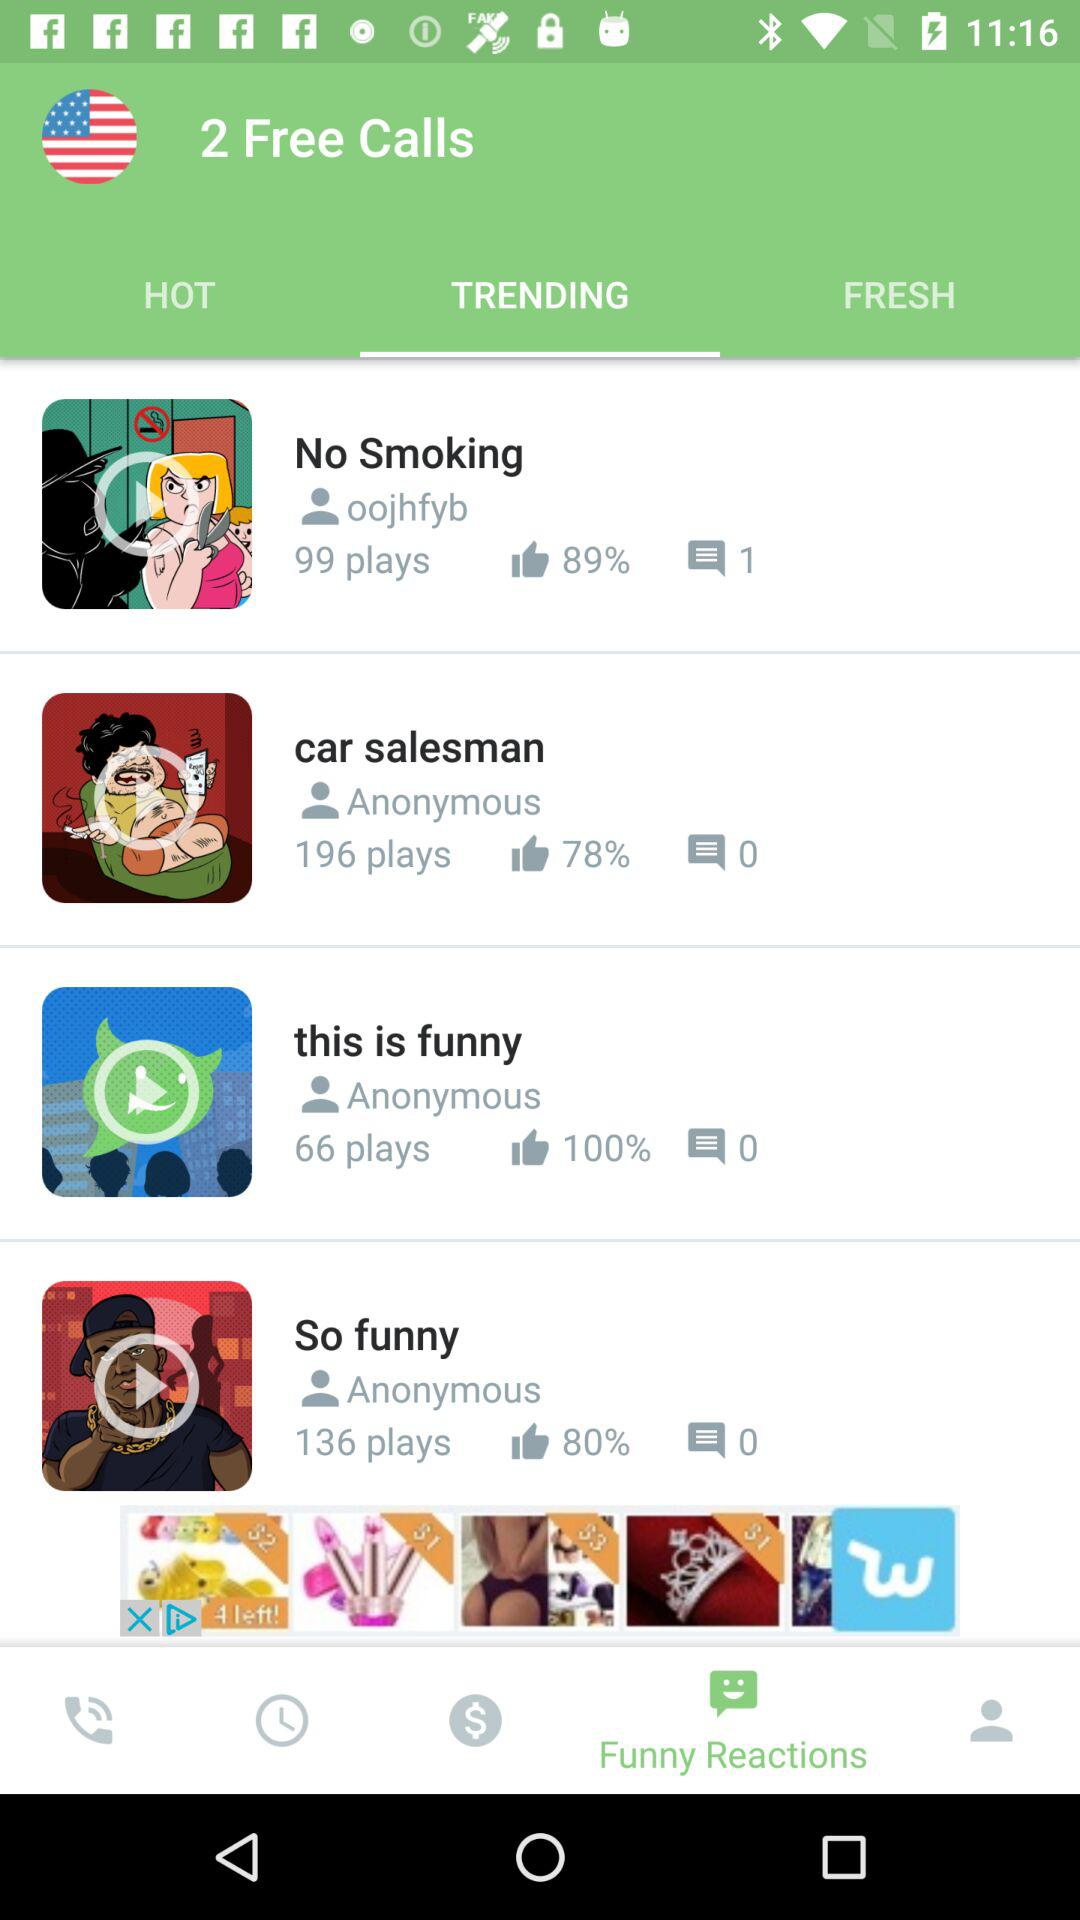How many likes are there on "this is funny"? There are 100% likes on "this is funny". 